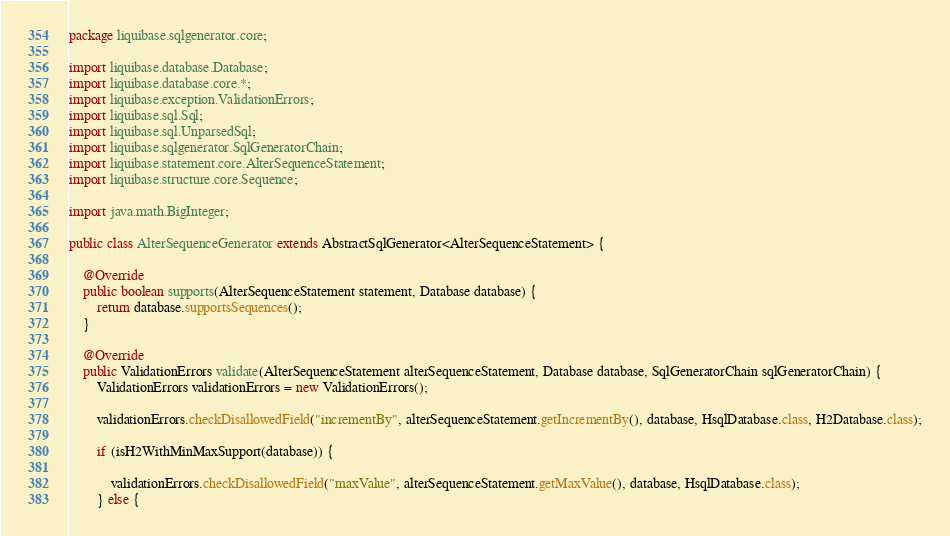<code> <loc_0><loc_0><loc_500><loc_500><_Java_>package liquibase.sqlgenerator.core;

import liquibase.database.Database;
import liquibase.database.core.*;
import liquibase.exception.ValidationErrors;
import liquibase.sql.Sql;
import liquibase.sql.UnparsedSql;
import liquibase.sqlgenerator.SqlGeneratorChain;
import liquibase.statement.core.AlterSequenceStatement;
import liquibase.structure.core.Sequence;

import java.math.BigInteger;

public class AlterSequenceGenerator extends AbstractSqlGenerator<AlterSequenceStatement> {

    @Override
    public boolean supports(AlterSequenceStatement statement, Database database) {
        return database.supportsSequences();
    }

    @Override
    public ValidationErrors validate(AlterSequenceStatement alterSequenceStatement, Database database, SqlGeneratorChain sqlGeneratorChain) {
        ValidationErrors validationErrors = new ValidationErrors();

        validationErrors.checkDisallowedField("incrementBy", alterSequenceStatement.getIncrementBy(), database, HsqlDatabase.class, H2Database.class);

        if (isH2WithMinMaxSupport(database)) {

            validationErrors.checkDisallowedField("maxValue", alterSequenceStatement.getMaxValue(), database, HsqlDatabase.class);
        } else {
</code> 